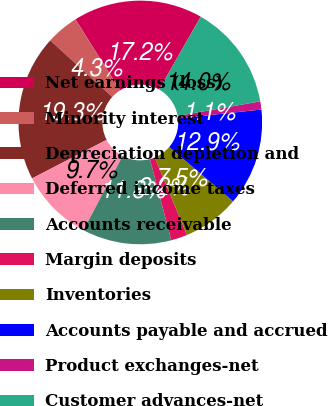<chart> <loc_0><loc_0><loc_500><loc_500><pie_chart><fcel>Net earnings (loss)<fcel>Minority interest<fcel>Depreciation depletion and<fcel>Deferred income taxes<fcel>Accounts receivable<fcel>Margin deposits<fcel>Inventories<fcel>Accounts payable and accrued<fcel>Product exchanges-net<fcel>Customer advances-net<nl><fcel>17.2%<fcel>4.31%<fcel>19.35%<fcel>9.68%<fcel>11.83%<fcel>2.16%<fcel>7.53%<fcel>12.9%<fcel>1.08%<fcel>13.97%<nl></chart> 